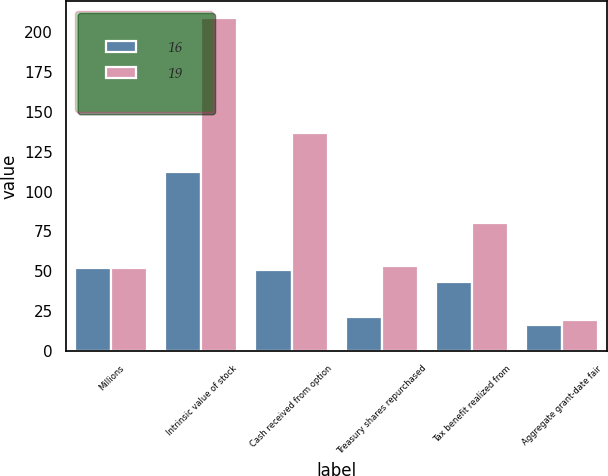Convert chart. <chart><loc_0><loc_0><loc_500><loc_500><stacked_bar_chart><ecel><fcel>Millions<fcel>Intrinsic value of stock<fcel>Cash received from option<fcel>Treasury shares repurchased<fcel>Tax benefit realized from<fcel>Aggregate grant-date fair<nl><fcel>16<fcel>52<fcel>112<fcel>51<fcel>21<fcel>43<fcel>16<nl><fcel>19<fcel>52<fcel>209<fcel>137<fcel>53<fcel>80<fcel>19<nl></chart> 